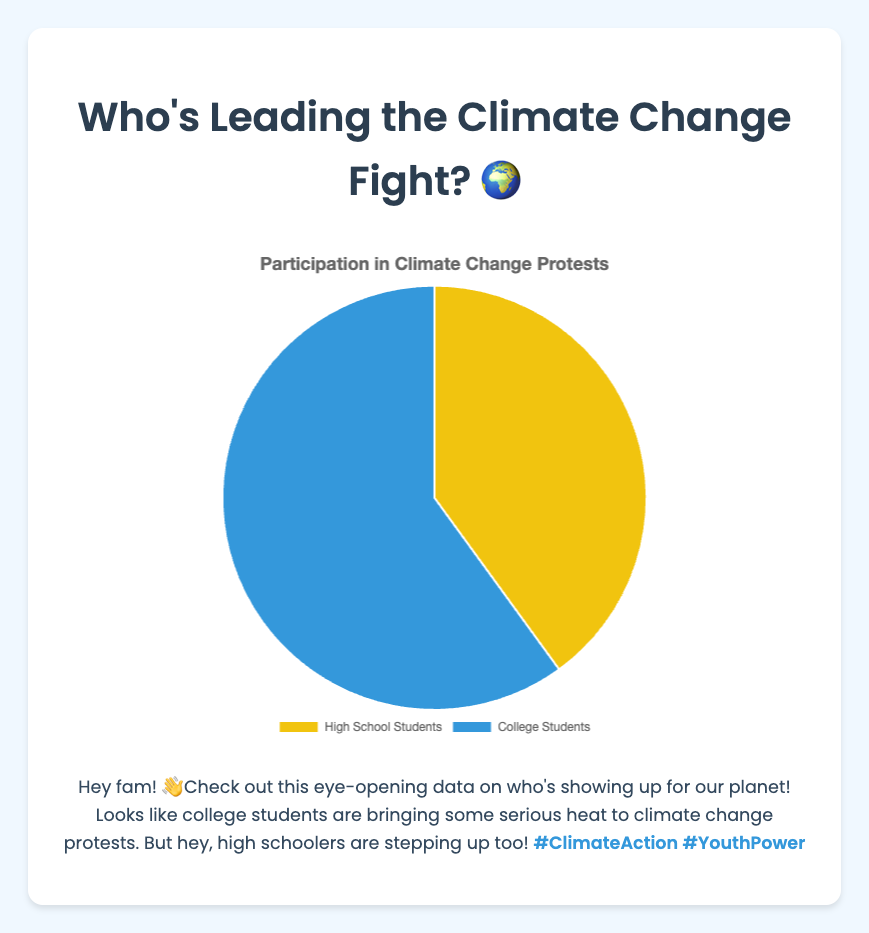What percentage of high school students participated in climate change protests? The pie chart indicates that the proportion of high school students is 40%. By referring to the section of the chart labeled for high school students, you can directly see the percentage.
Answer: 40% What percentage of college students participated in climate change protests? According to the pie chart, the proportion of college students is 60%. This information is visible in the chart's section labeled for college students.
Answer: 60% Which group has a higher percentage of participation in climate change protests, high school or college students? By comparing the two sections of the pie chart, it's clear that the college students' section (60%) is larger than the high school students' section (40%).
Answer: College students How much more participation do college students have in climate change protests compared to high school students? The percentage for college students is 60% and for high school students is 40%. The difference in participation is calculated as 60% - 40% = 20%.
Answer: 20% What is the sum of the percentages for both groups participating in climate change protests? The sum of the percentages is found by adding the two proportions: 40% (high school students) + 60% (college students) = 100%.
Answer: 100% If you combine the high school and college student participation, what is the average participation percentage? The average participation is calculated by adding the two percentages and dividing by the number of groups: (40% + 60%) / 2 = 50%.
Answer: 50% Which color represents high school students' participation in the pie chart? The high school students' section is colored yellow, visible by looking at the corresponding section labeled "High School Students".
Answer: Yellow Which color represents college students’ participation in the pie chart? The pie chart shows that the section for college students is colored blue, indicated by the segment labeled "College Students".
Answer: Blue How much more likely is a college student to participate in climate change protests compared to a high school student? To determine how many times more likely college students are compared to high school students: College percentage (60%) / High school percentage (40%) = 1.5. This means college students are 1.5 times more likely to participate.
Answer: 1.5 times 